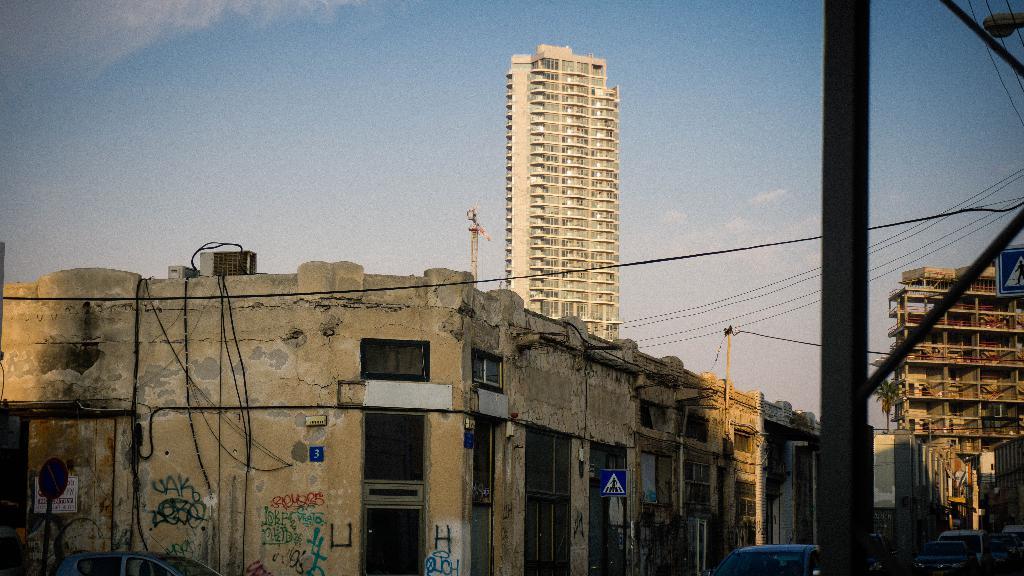Please provide a concise description of this image. In this image I can see number of buildings, few poles, number of wires, few sign boards and on the bottom right side of this image I can see number of vehicles. I can see a tree on the right side and in the background I can see clouds and the sky. In the front I can see something is written on the wall. 